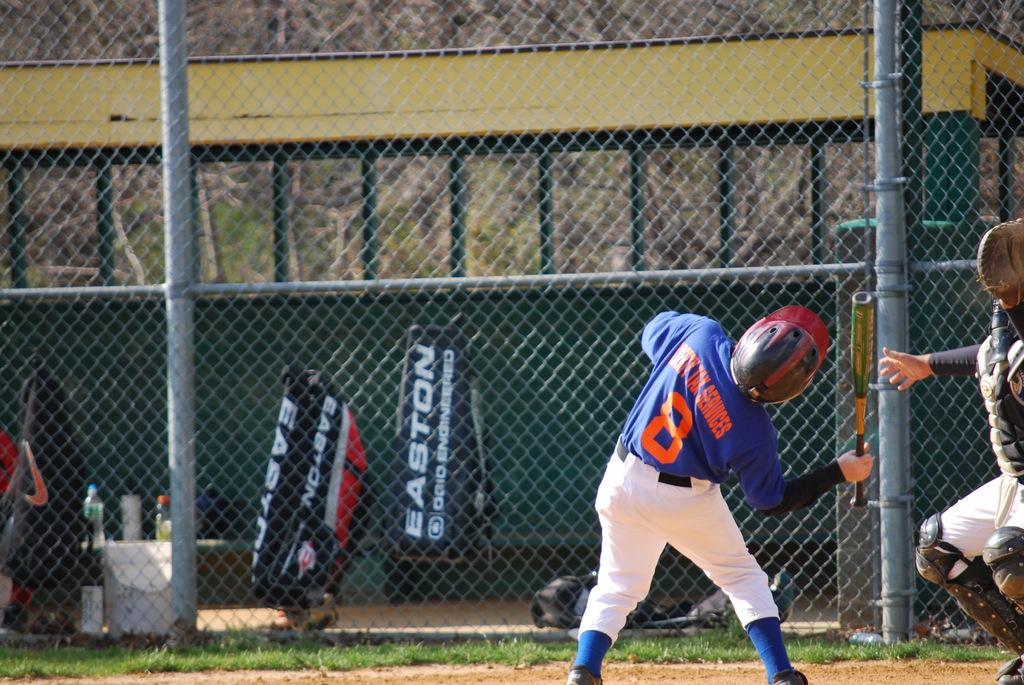<image>
Summarize the visual content of the image. child holding bat wearing uniform for liberty tax services looking up for the ball 